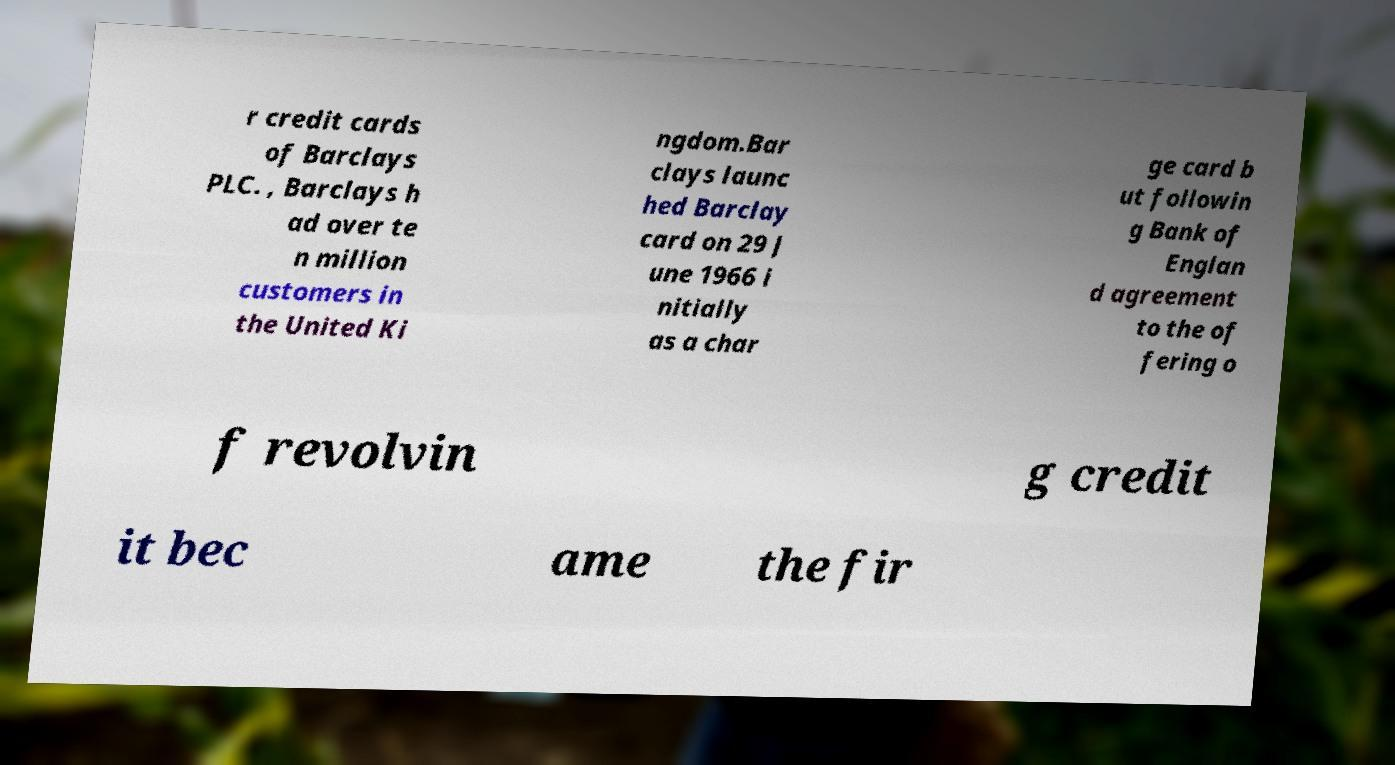Please read and relay the text visible in this image. What does it say? r credit cards of Barclays PLC. , Barclays h ad over te n million customers in the United Ki ngdom.Bar clays launc hed Barclay card on 29 J une 1966 i nitially as a char ge card b ut followin g Bank of Englan d agreement to the of fering o f revolvin g credit it bec ame the fir 